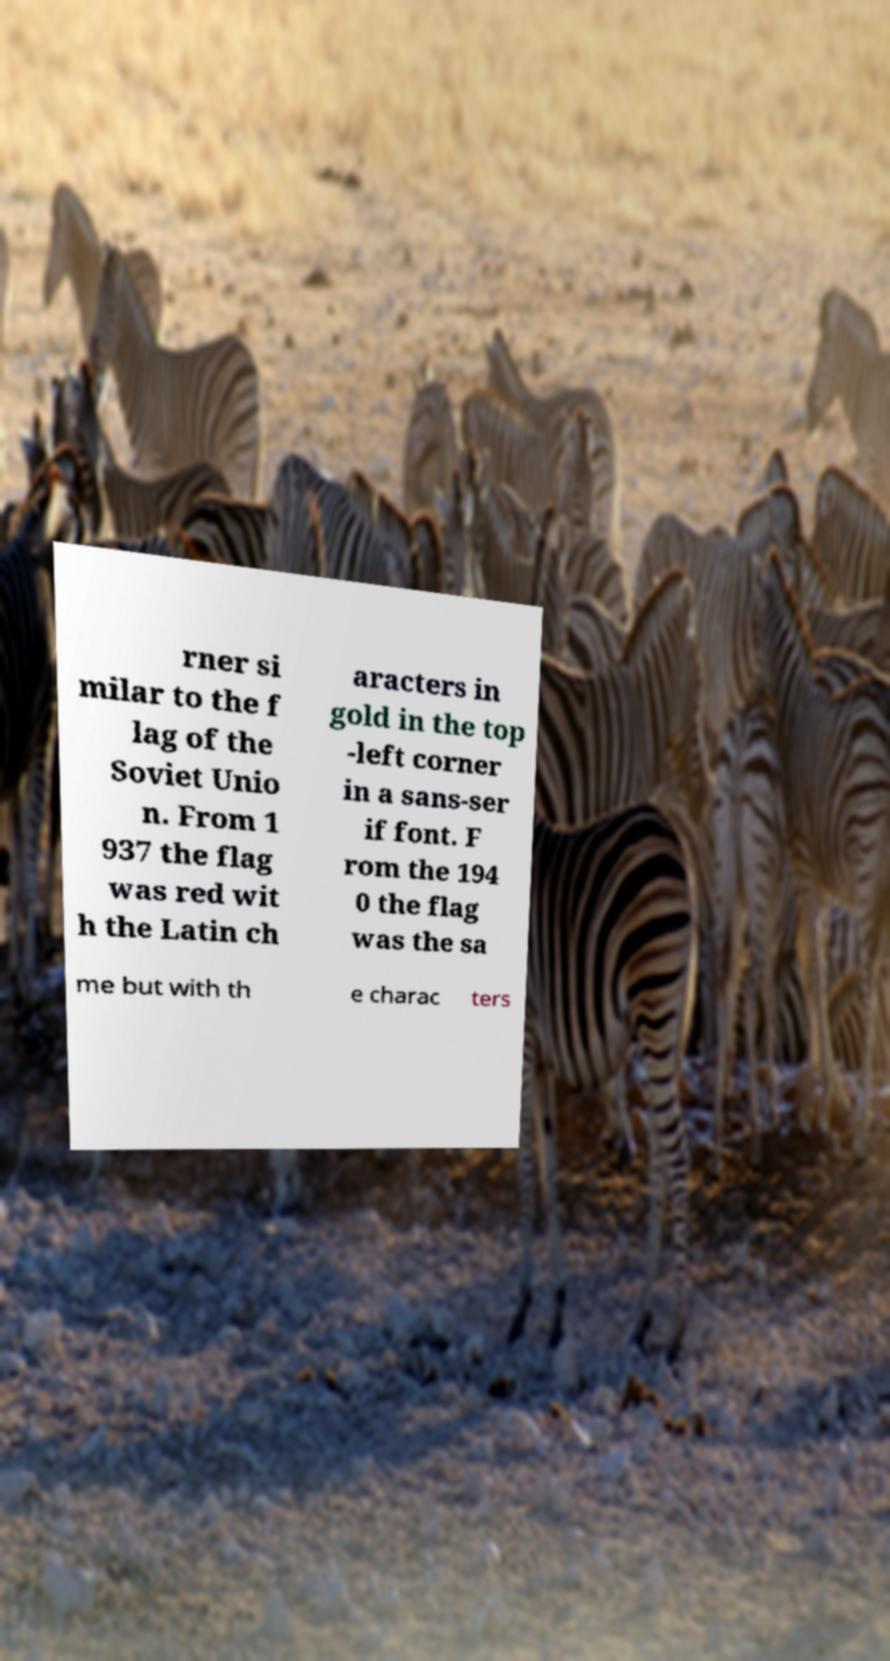There's text embedded in this image that I need extracted. Can you transcribe it verbatim? rner si milar to the f lag of the Soviet Unio n. From 1 937 the flag was red wit h the Latin ch aracters in gold in the top -left corner in a sans-ser if font. F rom the 194 0 the flag was the sa me but with th e charac ters 